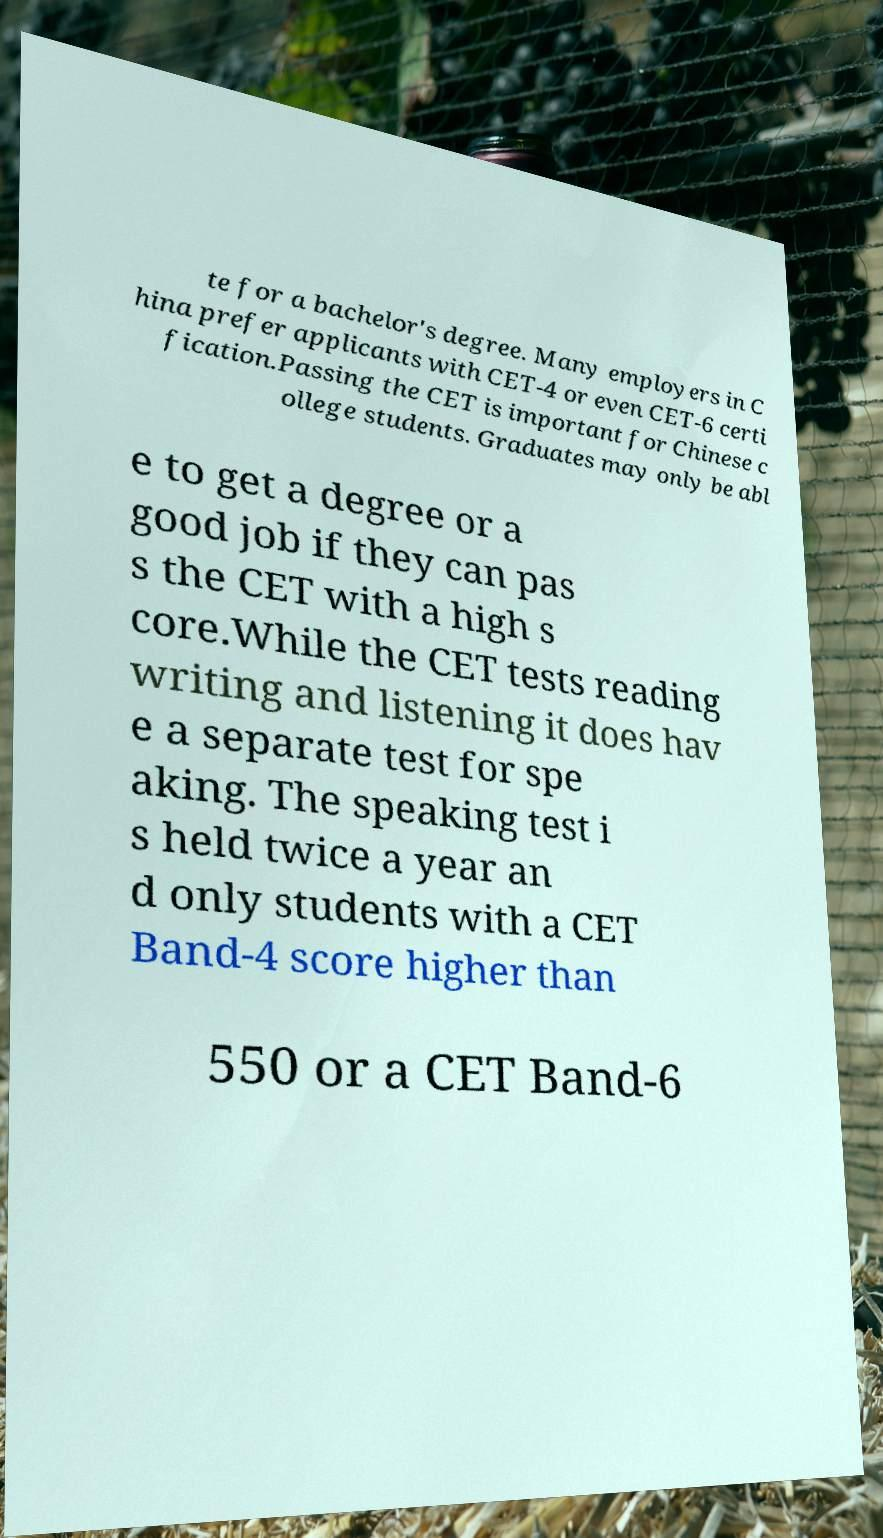Please read and relay the text visible in this image. What does it say? te for a bachelor's degree. Many employers in C hina prefer applicants with CET-4 or even CET-6 certi fication.Passing the CET is important for Chinese c ollege students. Graduates may only be abl e to get a degree or a good job if they can pas s the CET with a high s core.While the CET tests reading writing and listening it does hav e a separate test for spe aking. The speaking test i s held twice a year an d only students with a CET Band-4 score higher than 550 or a CET Band-6 